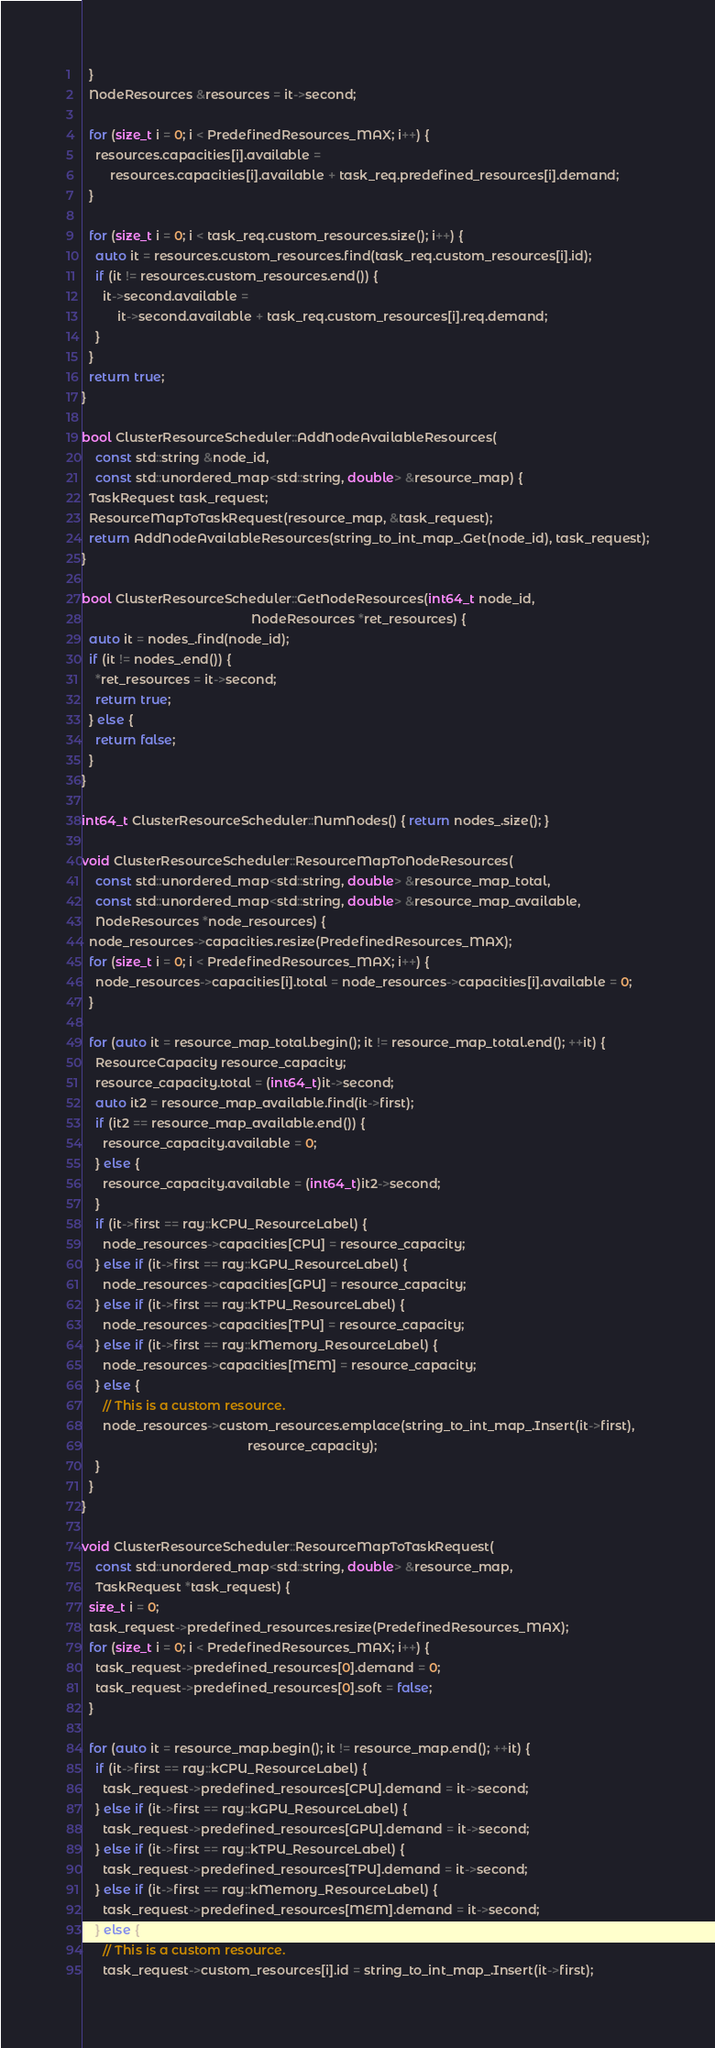Convert code to text. <code><loc_0><loc_0><loc_500><loc_500><_C++_>  }
  NodeResources &resources = it->second;

  for (size_t i = 0; i < PredefinedResources_MAX; i++) {
    resources.capacities[i].available =
        resources.capacities[i].available + task_req.predefined_resources[i].demand;
  }

  for (size_t i = 0; i < task_req.custom_resources.size(); i++) {
    auto it = resources.custom_resources.find(task_req.custom_resources[i].id);
    if (it != resources.custom_resources.end()) {
      it->second.available =
          it->second.available + task_req.custom_resources[i].req.demand;
    }
  }
  return true;
}

bool ClusterResourceScheduler::AddNodeAvailableResources(
    const std::string &node_id,
    const std::unordered_map<std::string, double> &resource_map) {
  TaskRequest task_request;
  ResourceMapToTaskRequest(resource_map, &task_request);
  return AddNodeAvailableResources(string_to_int_map_.Get(node_id), task_request);
}

bool ClusterResourceScheduler::GetNodeResources(int64_t node_id,
                                                NodeResources *ret_resources) {
  auto it = nodes_.find(node_id);
  if (it != nodes_.end()) {
    *ret_resources = it->second;
    return true;
  } else {
    return false;
  }
}

int64_t ClusterResourceScheduler::NumNodes() { return nodes_.size(); }

void ClusterResourceScheduler::ResourceMapToNodeResources(
    const std::unordered_map<std::string, double> &resource_map_total,
    const std::unordered_map<std::string, double> &resource_map_available,
    NodeResources *node_resources) {
  node_resources->capacities.resize(PredefinedResources_MAX);
  for (size_t i = 0; i < PredefinedResources_MAX; i++) {
    node_resources->capacities[i].total = node_resources->capacities[i].available = 0;
  }

  for (auto it = resource_map_total.begin(); it != resource_map_total.end(); ++it) {
    ResourceCapacity resource_capacity;
    resource_capacity.total = (int64_t)it->second;
    auto it2 = resource_map_available.find(it->first);
    if (it2 == resource_map_available.end()) {
      resource_capacity.available = 0;
    } else {
      resource_capacity.available = (int64_t)it2->second;
    }
    if (it->first == ray::kCPU_ResourceLabel) {
      node_resources->capacities[CPU] = resource_capacity;
    } else if (it->first == ray::kGPU_ResourceLabel) {
      node_resources->capacities[GPU] = resource_capacity;
    } else if (it->first == ray::kTPU_ResourceLabel) {
      node_resources->capacities[TPU] = resource_capacity;
    } else if (it->first == ray::kMemory_ResourceLabel) {
      node_resources->capacities[MEM] = resource_capacity;
    } else {
      // This is a custom resource.
      node_resources->custom_resources.emplace(string_to_int_map_.Insert(it->first),
                                               resource_capacity);
    }
  }
}

void ClusterResourceScheduler::ResourceMapToTaskRequest(
    const std::unordered_map<std::string, double> &resource_map,
    TaskRequest *task_request) {
  size_t i = 0;
  task_request->predefined_resources.resize(PredefinedResources_MAX);
  for (size_t i = 0; i < PredefinedResources_MAX; i++) {
    task_request->predefined_resources[0].demand = 0;
    task_request->predefined_resources[0].soft = false;
  }

  for (auto it = resource_map.begin(); it != resource_map.end(); ++it) {
    if (it->first == ray::kCPU_ResourceLabel) {
      task_request->predefined_resources[CPU].demand = it->second;
    } else if (it->first == ray::kGPU_ResourceLabel) {
      task_request->predefined_resources[GPU].demand = it->second;
    } else if (it->first == ray::kTPU_ResourceLabel) {
      task_request->predefined_resources[TPU].demand = it->second;
    } else if (it->first == ray::kMemory_ResourceLabel) {
      task_request->predefined_resources[MEM].demand = it->second;
    } else {
      // This is a custom resource.
      task_request->custom_resources[i].id = string_to_int_map_.Insert(it->first);</code> 